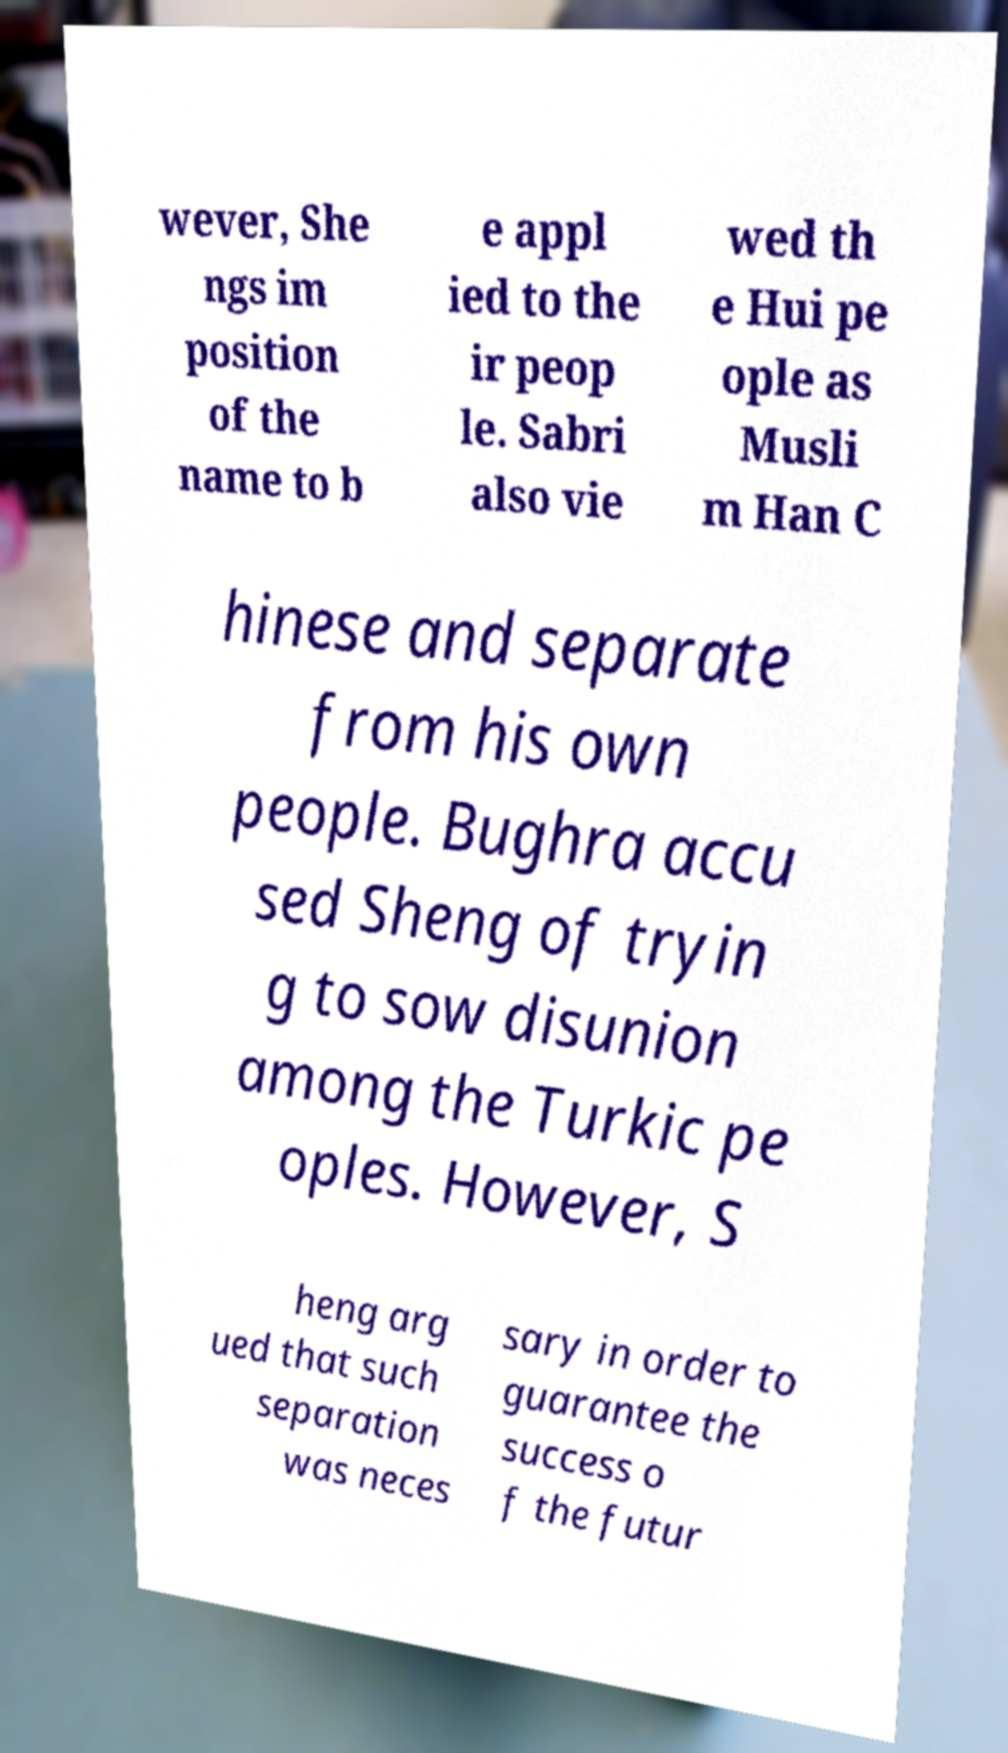Please read and relay the text visible in this image. What does it say? wever, She ngs im position of the name to b e appl ied to the ir peop le. Sabri also vie wed th e Hui pe ople as Musli m Han C hinese and separate from his own people. Bughra accu sed Sheng of tryin g to sow disunion among the Turkic pe oples. However, S heng arg ued that such separation was neces sary in order to guarantee the success o f the futur 